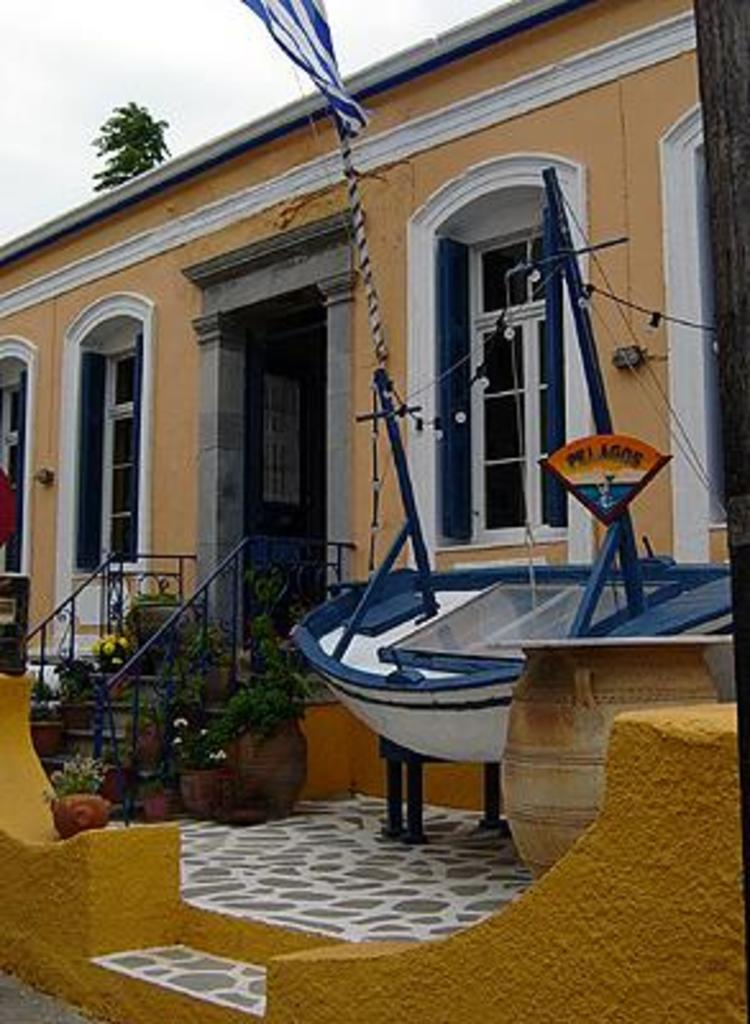What type of structure is visible in the image? There is a house in the image. What is located in front of the house? There is a staircase in front of the house. Are there any plants on the staircase? Yes, the staircase has plants on it. What else can be seen in the image besides the house and staircase? There is a boat and a few other objects in the image. What is visible in the background of the image? There is a tree in the background of the image. What type of feather can be seen on the boat in the image? There is no feather visible on the boat in the image. How many passengers are on the boat in the image? There is no boat with passengers in the image; it only shows a boat without any people. 